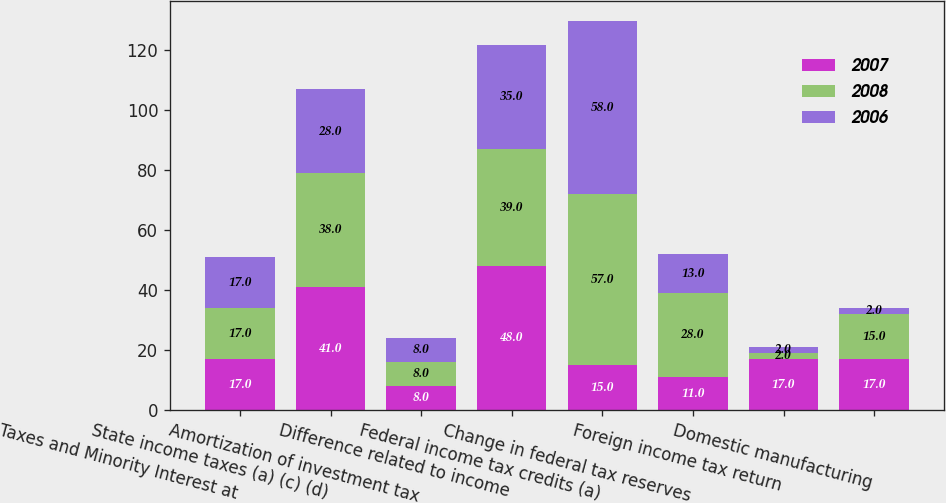Convert chart. <chart><loc_0><loc_0><loc_500><loc_500><stacked_bar_chart><ecel><fcel>Taxes and Minority Interest at<fcel>State income taxes (a) (c) (d)<fcel>Amortization of investment tax<fcel>Difference related to income<fcel>Federal income tax credits (a)<fcel>Change in federal tax reserves<fcel>Foreign income tax return<fcel>Domestic manufacturing<nl><fcel>2007<fcel>17<fcel>41<fcel>8<fcel>48<fcel>15<fcel>11<fcel>17<fcel>17<nl><fcel>2008<fcel>17<fcel>38<fcel>8<fcel>39<fcel>57<fcel>28<fcel>2<fcel>15<nl><fcel>2006<fcel>17<fcel>28<fcel>8<fcel>35<fcel>58<fcel>13<fcel>2<fcel>2<nl></chart> 